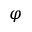Convert formula to latex. <formula><loc_0><loc_0><loc_500><loc_500>\varphi</formula> 